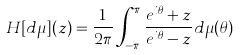Convert formula to latex. <formula><loc_0><loc_0><loc_500><loc_500>H [ d \mu ] ( z ) = \frac { 1 } { 2 \pi } \int _ { - \pi } ^ { \pi } \frac { e ^ { i \theta } + z } { e ^ { i \theta } - z } d \mu ( \theta )</formula> 